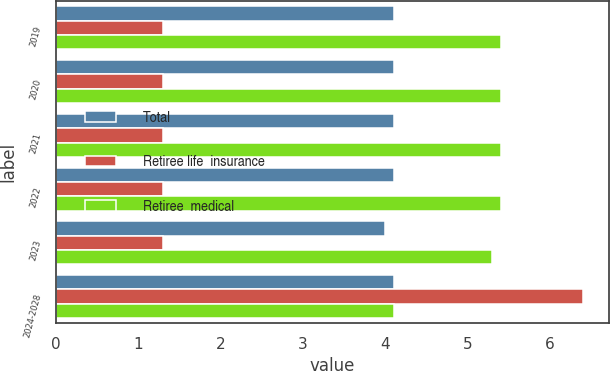Convert chart. <chart><loc_0><loc_0><loc_500><loc_500><stacked_bar_chart><ecel><fcel>2019<fcel>2020<fcel>2021<fcel>2022<fcel>2023<fcel>2024-2028<nl><fcel>Total<fcel>4.1<fcel>4.1<fcel>4.1<fcel>4.1<fcel>4<fcel>4.1<nl><fcel>Retiree life  insurance<fcel>1.3<fcel>1.3<fcel>1.3<fcel>1.3<fcel>1.3<fcel>6.4<nl><fcel>Retiree  medical<fcel>5.4<fcel>5.4<fcel>5.4<fcel>5.4<fcel>5.3<fcel>4.1<nl></chart> 